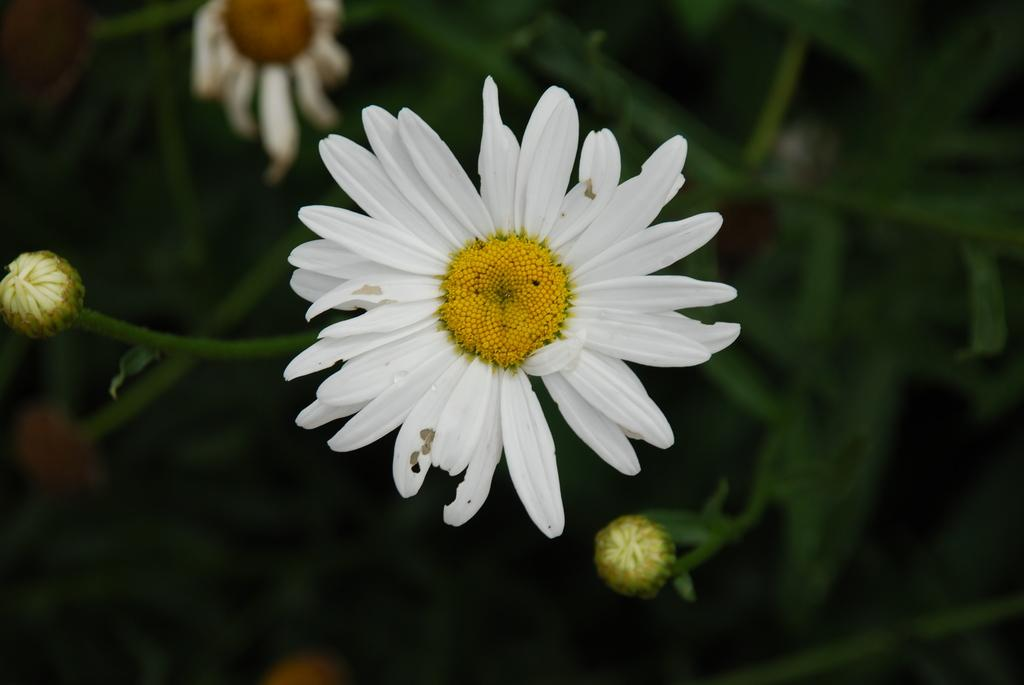What type of plant is visible in the image? There is a plant in the image, and it has buds and flowers. Can you describe the main flower in the image? The flower in the center of the image has petals and pollen grains. What is the background of the image like? The background of the image is blurry. What type of suit is the flower wearing in the image? There is no suit present in the image, as flowers do not wear clothing. 